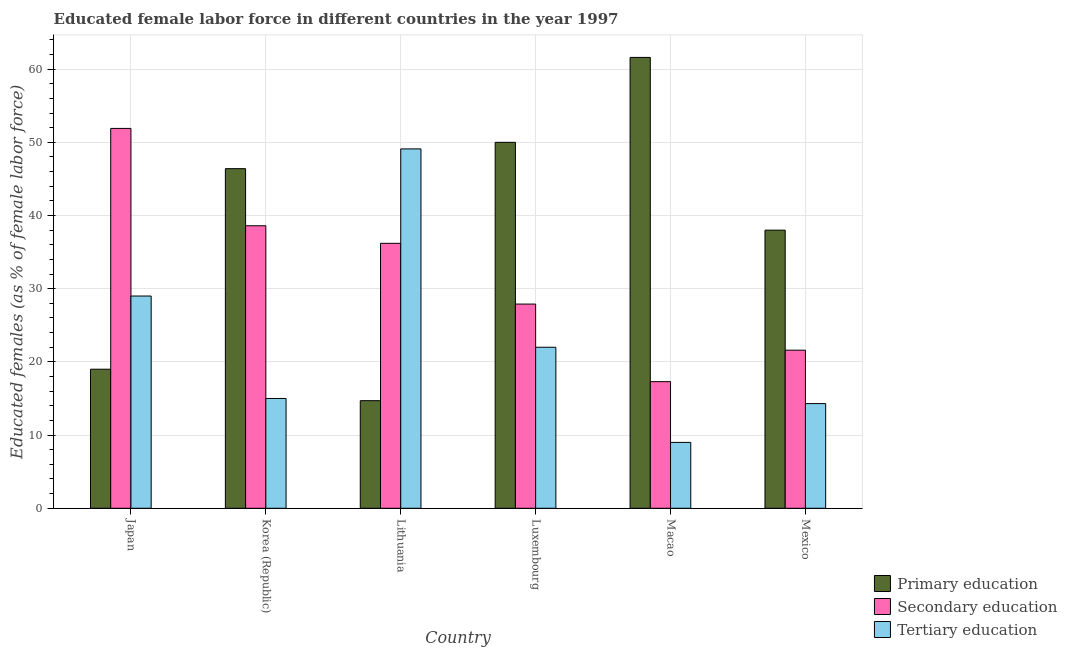How many different coloured bars are there?
Your response must be concise. 3. Are the number of bars per tick equal to the number of legend labels?
Your answer should be very brief. Yes. How many bars are there on the 3rd tick from the right?
Your answer should be compact. 3. What is the label of the 3rd group of bars from the left?
Offer a terse response. Lithuania. What is the percentage of female labor force who received secondary education in Mexico?
Your response must be concise. 21.6. Across all countries, what is the maximum percentage of female labor force who received secondary education?
Your response must be concise. 51.9. Across all countries, what is the minimum percentage of female labor force who received secondary education?
Your answer should be compact. 17.3. In which country was the percentage of female labor force who received tertiary education maximum?
Your answer should be very brief. Lithuania. In which country was the percentage of female labor force who received secondary education minimum?
Your response must be concise. Macao. What is the total percentage of female labor force who received primary education in the graph?
Provide a succinct answer. 229.7. What is the difference between the percentage of female labor force who received primary education in Korea (Republic) and that in Mexico?
Ensure brevity in your answer.  8.4. What is the difference between the percentage of female labor force who received tertiary education in Luxembourg and the percentage of female labor force who received secondary education in Lithuania?
Provide a short and direct response. -14.2. What is the average percentage of female labor force who received secondary education per country?
Offer a very short reply. 32.25. What is the difference between the percentage of female labor force who received secondary education and percentage of female labor force who received tertiary education in Macao?
Your answer should be very brief. 8.3. What is the ratio of the percentage of female labor force who received primary education in Luxembourg to that in Mexico?
Give a very brief answer. 1.32. Is the percentage of female labor force who received tertiary education in Korea (Republic) less than that in Luxembourg?
Your answer should be compact. Yes. What is the difference between the highest and the second highest percentage of female labor force who received tertiary education?
Make the answer very short. 20.1. What is the difference between the highest and the lowest percentage of female labor force who received tertiary education?
Keep it short and to the point. 40.1. In how many countries, is the percentage of female labor force who received secondary education greater than the average percentage of female labor force who received secondary education taken over all countries?
Offer a very short reply. 3. Is the sum of the percentage of female labor force who received tertiary education in Lithuania and Macao greater than the maximum percentage of female labor force who received secondary education across all countries?
Give a very brief answer. Yes. What does the 3rd bar from the left in Lithuania represents?
Offer a very short reply. Tertiary education. What does the 3rd bar from the right in Korea (Republic) represents?
Make the answer very short. Primary education. Is it the case that in every country, the sum of the percentage of female labor force who received primary education and percentage of female labor force who received secondary education is greater than the percentage of female labor force who received tertiary education?
Keep it short and to the point. Yes. How many bars are there?
Offer a terse response. 18. Are all the bars in the graph horizontal?
Your answer should be compact. No. What is the difference between two consecutive major ticks on the Y-axis?
Offer a terse response. 10. Are the values on the major ticks of Y-axis written in scientific E-notation?
Offer a terse response. No. Does the graph contain any zero values?
Offer a terse response. No. What is the title of the graph?
Provide a succinct answer. Educated female labor force in different countries in the year 1997. What is the label or title of the X-axis?
Offer a very short reply. Country. What is the label or title of the Y-axis?
Give a very brief answer. Educated females (as % of female labor force). What is the Educated females (as % of female labor force) in Primary education in Japan?
Provide a short and direct response. 19. What is the Educated females (as % of female labor force) in Secondary education in Japan?
Offer a terse response. 51.9. What is the Educated females (as % of female labor force) of Tertiary education in Japan?
Keep it short and to the point. 29. What is the Educated females (as % of female labor force) of Primary education in Korea (Republic)?
Make the answer very short. 46.4. What is the Educated females (as % of female labor force) of Secondary education in Korea (Republic)?
Your response must be concise. 38.6. What is the Educated females (as % of female labor force) in Tertiary education in Korea (Republic)?
Provide a short and direct response. 15. What is the Educated females (as % of female labor force) in Primary education in Lithuania?
Your answer should be compact. 14.7. What is the Educated females (as % of female labor force) of Secondary education in Lithuania?
Offer a terse response. 36.2. What is the Educated females (as % of female labor force) in Tertiary education in Lithuania?
Offer a terse response. 49.1. What is the Educated females (as % of female labor force) of Secondary education in Luxembourg?
Offer a terse response. 27.9. What is the Educated females (as % of female labor force) in Primary education in Macao?
Your answer should be very brief. 61.6. What is the Educated females (as % of female labor force) of Secondary education in Macao?
Offer a terse response. 17.3. What is the Educated females (as % of female labor force) in Primary education in Mexico?
Give a very brief answer. 38. What is the Educated females (as % of female labor force) of Secondary education in Mexico?
Keep it short and to the point. 21.6. What is the Educated females (as % of female labor force) in Tertiary education in Mexico?
Offer a terse response. 14.3. Across all countries, what is the maximum Educated females (as % of female labor force) of Primary education?
Keep it short and to the point. 61.6. Across all countries, what is the maximum Educated females (as % of female labor force) of Secondary education?
Your response must be concise. 51.9. Across all countries, what is the maximum Educated females (as % of female labor force) in Tertiary education?
Provide a short and direct response. 49.1. Across all countries, what is the minimum Educated females (as % of female labor force) in Primary education?
Your answer should be compact. 14.7. Across all countries, what is the minimum Educated females (as % of female labor force) of Secondary education?
Provide a short and direct response. 17.3. Across all countries, what is the minimum Educated females (as % of female labor force) in Tertiary education?
Make the answer very short. 9. What is the total Educated females (as % of female labor force) of Primary education in the graph?
Your answer should be compact. 229.7. What is the total Educated females (as % of female labor force) of Secondary education in the graph?
Provide a succinct answer. 193.5. What is the total Educated females (as % of female labor force) in Tertiary education in the graph?
Give a very brief answer. 138.4. What is the difference between the Educated females (as % of female labor force) in Primary education in Japan and that in Korea (Republic)?
Provide a short and direct response. -27.4. What is the difference between the Educated females (as % of female labor force) of Tertiary education in Japan and that in Korea (Republic)?
Your response must be concise. 14. What is the difference between the Educated females (as % of female labor force) of Primary education in Japan and that in Lithuania?
Make the answer very short. 4.3. What is the difference between the Educated females (as % of female labor force) in Secondary education in Japan and that in Lithuania?
Offer a terse response. 15.7. What is the difference between the Educated females (as % of female labor force) of Tertiary education in Japan and that in Lithuania?
Your response must be concise. -20.1. What is the difference between the Educated females (as % of female labor force) in Primary education in Japan and that in Luxembourg?
Your answer should be very brief. -31. What is the difference between the Educated females (as % of female labor force) in Secondary education in Japan and that in Luxembourg?
Provide a succinct answer. 24. What is the difference between the Educated females (as % of female labor force) in Primary education in Japan and that in Macao?
Give a very brief answer. -42.6. What is the difference between the Educated females (as % of female labor force) in Secondary education in Japan and that in Macao?
Offer a terse response. 34.6. What is the difference between the Educated females (as % of female labor force) in Secondary education in Japan and that in Mexico?
Provide a short and direct response. 30.3. What is the difference between the Educated females (as % of female labor force) of Primary education in Korea (Republic) and that in Lithuania?
Give a very brief answer. 31.7. What is the difference between the Educated females (as % of female labor force) of Secondary education in Korea (Republic) and that in Lithuania?
Offer a very short reply. 2.4. What is the difference between the Educated females (as % of female labor force) of Tertiary education in Korea (Republic) and that in Lithuania?
Your answer should be very brief. -34.1. What is the difference between the Educated females (as % of female labor force) of Primary education in Korea (Republic) and that in Luxembourg?
Offer a very short reply. -3.6. What is the difference between the Educated females (as % of female labor force) of Secondary education in Korea (Republic) and that in Luxembourg?
Provide a succinct answer. 10.7. What is the difference between the Educated females (as % of female labor force) in Primary education in Korea (Republic) and that in Macao?
Offer a terse response. -15.2. What is the difference between the Educated females (as % of female labor force) in Secondary education in Korea (Republic) and that in Macao?
Give a very brief answer. 21.3. What is the difference between the Educated females (as % of female labor force) of Tertiary education in Korea (Republic) and that in Macao?
Your answer should be compact. 6. What is the difference between the Educated females (as % of female labor force) in Tertiary education in Korea (Republic) and that in Mexico?
Make the answer very short. 0.7. What is the difference between the Educated females (as % of female labor force) in Primary education in Lithuania and that in Luxembourg?
Offer a very short reply. -35.3. What is the difference between the Educated females (as % of female labor force) of Secondary education in Lithuania and that in Luxembourg?
Ensure brevity in your answer.  8.3. What is the difference between the Educated females (as % of female labor force) of Tertiary education in Lithuania and that in Luxembourg?
Offer a very short reply. 27.1. What is the difference between the Educated females (as % of female labor force) of Primary education in Lithuania and that in Macao?
Your answer should be very brief. -46.9. What is the difference between the Educated females (as % of female labor force) in Secondary education in Lithuania and that in Macao?
Make the answer very short. 18.9. What is the difference between the Educated females (as % of female labor force) in Tertiary education in Lithuania and that in Macao?
Provide a succinct answer. 40.1. What is the difference between the Educated females (as % of female labor force) in Primary education in Lithuania and that in Mexico?
Your answer should be compact. -23.3. What is the difference between the Educated females (as % of female labor force) in Tertiary education in Lithuania and that in Mexico?
Give a very brief answer. 34.8. What is the difference between the Educated females (as % of female labor force) of Tertiary education in Luxembourg and that in Macao?
Keep it short and to the point. 13. What is the difference between the Educated females (as % of female labor force) in Secondary education in Luxembourg and that in Mexico?
Give a very brief answer. 6.3. What is the difference between the Educated females (as % of female labor force) in Primary education in Macao and that in Mexico?
Provide a short and direct response. 23.6. What is the difference between the Educated females (as % of female labor force) of Tertiary education in Macao and that in Mexico?
Offer a terse response. -5.3. What is the difference between the Educated females (as % of female labor force) in Primary education in Japan and the Educated females (as % of female labor force) in Secondary education in Korea (Republic)?
Provide a short and direct response. -19.6. What is the difference between the Educated females (as % of female labor force) in Primary education in Japan and the Educated females (as % of female labor force) in Tertiary education in Korea (Republic)?
Your answer should be very brief. 4. What is the difference between the Educated females (as % of female labor force) in Secondary education in Japan and the Educated females (as % of female labor force) in Tertiary education in Korea (Republic)?
Your response must be concise. 36.9. What is the difference between the Educated females (as % of female labor force) in Primary education in Japan and the Educated females (as % of female labor force) in Secondary education in Lithuania?
Make the answer very short. -17.2. What is the difference between the Educated females (as % of female labor force) of Primary education in Japan and the Educated females (as % of female labor force) of Tertiary education in Lithuania?
Give a very brief answer. -30.1. What is the difference between the Educated females (as % of female labor force) of Primary education in Japan and the Educated females (as % of female labor force) of Secondary education in Luxembourg?
Give a very brief answer. -8.9. What is the difference between the Educated females (as % of female labor force) of Primary education in Japan and the Educated females (as % of female labor force) of Tertiary education in Luxembourg?
Provide a succinct answer. -3. What is the difference between the Educated females (as % of female labor force) in Secondary education in Japan and the Educated females (as % of female labor force) in Tertiary education in Luxembourg?
Provide a short and direct response. 29.9. What is the difference between the Educated females (as % of female labor force) of Primary education in Japan and the Educated females (as % of female labor force) of Tertiary education in Macao?
Your answer should be very brief. 10. What is the difference between the Educated females (as % of female labor force) of Secondary education in Japan and the Educated females (as % of female labor force) of Tertiary education in Macao?
Keep it short and to the point. 42.9. What is the difference between the Educated females (as % of female labor force) of Primary education in Japan and the Educated females (as % of female labor force) of Secondary education in Mexico?
Your response must be concise. -2.6. What is the difference between the Educated females (as % of female labor force) of Secondary education in Japan and the Educated females (as % of female labor force) of Tertiary education in Mexico?
Your answer should be compact. 37.6. What is the difference between the Educated females (as % of female labor force) in Primary education in Korea (Republic) and the Educated females (as % of female labor force) in Secondary education in Lithuania?
Make the answer very short. 10.2. What is the difference between the Educated females (as % of female labor force) in Primary education in Korea (Republic) and the Educated females (as % of female labor force) in Tertiary education in Lithuania?
Your answer should be compact. -2.7. What is the difference between the Educated females (as % of female labor force) of Secondary education in Korea (Republic) and the Educated females (as % of female labor force) of Tertiary education in Lithuania?
Provide a succinct answer. -10.5. What is the difference between the Educated females (as % of female labor force) of Primary education in Korea (Republic) and the Educated females (as % of female labor force) of Secondary education in Luxembourg?
Keep it short and to the point. 18.5. What is the difference between the Educated females (as % of female labor force) in Primary education in Korea (Republic) and the Educated females (as % of female labor force) in Tertiary education in Luxembourg?
Provide a short and direct response. 24.4. What is the difference between the Educated females (as % of female labor force) of Primary education in Korea (Republic) and the Educated females (as % of female labor force) of Secondary education in Macao?
Give a very brief answer. 29.1. What is the difference between the Educated females (as % of female labor force) in Primary education in Korea (Republic) and the Educated females (as % of female labor force) in Tertiary education in Macao?
Provide a short and direct response. 37.4. What is the difference between the Educated females (as % of female labor force) of Secondary education in Korea (Republic) and the Educated females (as % of female labor force) of Tertiary education in Macao?
Your answer should be compact. 29.6. What is the difference between the Educated females (as % of female labor force) in Primary education in Korea (Republic) and the Educated females (as % of female labor force) in Secondary education in Mexico?
Your answer should be very brief. 24.8. What is the difference between the Educated females (as % of female labor force) of Primary education in Korea (Republic) and the Educated females (as % of female labor force) of Tertiary education in Mexico?
Keep it short and to the point. 32.1. What is the difference between the Educated females (as % of female labor force) of Secondary education in Korea (Republic) and the Educated females (as % of female labor force) of Tertiary education in Mexico?
Offer a terse response. 24.3. What is the difference between the Educated females (as % of female labor force) of Primary education in Lithuania and the Educated females (as % of female labor force) of Secondary education in Luxembourg?
Keep it short and to the point. -13.2. What is the difference between the Educated females (as % of female labor force) of Secondary education in Lithuania and the Educated females (as % of female labor force) of Tertiary education in Luxembourg?
Ensure brevity in your answer.  14.2. What is the difference between the Educated females (as % of female labor force) of Secondary education in Lithuania and the Educated females (as % of female labor force) of Tertiary education in Macao?
Provide a succinct answer. 27.2. What is the difference between the Educated females (as % of female labor force) in Secondary education in Lithuania and the Educated females (as % of female labor force) in Tertiary education in Mexico?
Make the answer very short. 21.9. What is the difference between the Educated females (as % of female labor force) in Primary education in Luxembourg and the Educated females (as % of female labor force) in Secondary education in Macao?
Ensure brevity in your answer.  32.7. What is the difference between the Educated females (as % of female labor force) in Primary education in Luxembourg and the Educated females (as % of female labor force) in Tertiary education in Macao?
Your answer should be very brief. 41. What is the difference between the Educated females (as % of female labor force) in Primary education in Luxembourg and the Educated females (as % of female labor force) in Secondary education in Mexico?
Ensure brevity in your answer.  28.4. What is the difference between the Educated females (as % of female labor force) in Primary education in Luxembourg and the Educated females (as % of female labor force) in Tertiary education in Mexico?
Give a very brief answer. 35.7. What is the difference between the Educated females (as % of female labor force) in Primary education in Macao and the Educated females (as % of female labor force) in Tertiary education in Mexico?
Your answer should be very brief. 47.3. What is the average Educated females (as % of female labor force) of Primary education per country?
Keep it short and to the point. 38.28. What is the average Educated females (as % of female labor force) of Secondary education per country?
Your response must be concise. 32.25. What is the average Educated females (as % of female labor force) of Tertiary education per country?
Give a very brief answer. 23.07. What is the difference between the Educated females (as % of female labor force) in Primary education and Educated females (as % of female labor force) in Secondary education in Japan?
Give a very brief answer. -32.9. What is the difference between the Educated females (as % of female labor force) in Primary education and Educated females (as % of female labor force) in Tertiary education in Japan?
Offer a terse response. -10. What is the difference between the Educated females (as % of female labor force) of Secondary education and Educated females (as % of female labor force) of Tertiary education in Japan?
Make the answer very short. 22.9. What is the difference between the Educated females (as % of female labor force) in Primary education and Educated females (as % of female labor force) in Secondary education in Korea (Republic)?
Provide a succinct answer. 7.8. What is the difference between the Educated females (as % of female labor force) of Primary education and Educated females (as % of female labor force) of Tertiary education in Korea (Republic)?
Offer a terse response. 31.4. What is the difference between the Educated females (as % of female labor force) in Secondary education and Educated females (as % of female labor force) in Tertiary education in Korea (Republic)?
Offer a very short reply. 23.6. What is the difference between the Educated females (as % of female labor force) of Primary education and Educated females (as % of female labor force) of Secondary education in Lithuania?
Keep it short and to the point. -21.5. What is the difference between the Educated females (as % of female labor force) in Primary education and Educated females (as % of female labor force) in Tertiary education in Lithuania?
Your response must be concise. -34.4. What is the difference between the Educated females (as % of female labor force) in Secondary education and Educated females (as % of female labor force) in Tertiary education in Lithuania?
Ensure brevity in your answer.  -12.9. What is the difference between the Educated females (as % of female labor force) in Primary education and Educated females (as % of female labor force) in Secondary education in Luxembourg?
Give a very brief answer. 22.1. What is the difference between the Educated females (as % of female labor force) in Primary education and Educated females (as % of female labor force) in Tertiary education in Luxembourg?
Provide a succinct answer. 28. What is the difference between the Educated females (as % of female labor force) in Secondary education and Educated females (as % of female labor force) in Tertiary education in Luxembourg?
Offer a very short reply. 5.9. What is the difference between the Educated females (as % of female labor force) in Primary education and Educated females (as % of female labor force) in Secondary education in Macao?
Ensure brevity in your answer.  44.3. What is the difference between the Educated females (as % of female labor force) of Primary education and Educated females (as % of female labor force) of Tertiary education in Macao?
Keep it short and to the point. 52.6. What is the difference between the Educated females (as % of female labor force) of Secondary education and Educated females (as % of female labor force) of Tertiary education in Macao?
Offer a terse response. 8.3. What is the difference between the Educated females (as % of female labor force) of Primary education and Educated females (as % of female labor force) of Secondary education in Mexico?
Your answer should be very brief. 16.4. What is the difference between the Educated females (as % of female labor force) in Primary education and Educated females (as % of female labor force) in Tertiary education in Mexico?
Provide a short and direct response. 23.7. What is the ratio of the Educated females (as % of female labor force) of Primary education in Japan to that in Korea (Republic)?
Make the answer very short. 0.41. What is the ratio of the Educated females (as % of female labor force) in Secondary education in Japan to that in Korea (Republic)?
Provide a short and direct response. 1.34. What is the ratio of the Educated females (as % of female labor force) of Tertiary education in Japan to that in Korea (Republic)?
Your answer should be very brief. 1.93. What is the ratio of the Educated females (as % of female labor force) in Primary education in Japan to that in Lithuania?
Your answer should be very brief. 1.29. What is the ratio of the Educated females (as % of female labor force) of Secondary education in Japan to that in Lithuania?
Your response must be concise. 1.43. What is the ratio of the Educated females (as % of female labor force) of Tertiary education in Japan to that in Lithuania?
Provide a short and direct response. 0.59. What is the ratio of the Educated females (as % of female labor force) in Primary education in Japan to that in Luxembourg?
Give a very brief answer. 0.38. What is the ratio of the Educated females (as % of female labor force) of Secondary education in Japan to that in Luxembourg?
Give a very brief answer. 1.86. What is the ratio of the Educated females (as % of female labor force) in Tertiary education in Japan to that in Luxembourg?
Provide a succinct answer. 1.32. What is the ratio of the Educated females (as % of female labor force) of Primary education in Japan to that in Macao?
Give a very brief answer. 0.31. What is the ratio of the Educated females (as % of female labor force) in Tertiary education in Japan to that in Macao?
Offer a very short reply. 3.22. What is the ratio of the Educated females (as % of female labor force) in Secondary education in Japan to that in Mexico?
Offer a terse response. 2.4. What is the ratio of the Educated females (as % of female labor force) of Tertiary education in Japan to that in Mexico?
Ensure brevity in your answer.  2.03. What is the ratio of the Educated females (as % of female labor force) of Primary education in Korea (Republic) to that in Lithuania?
Your answer should be very brief. 3.16. What is the ratio of the Educated females (as % of female labor force) in Secondary education in Korea (Republic) to that in Lithuania?
Ensure brevity in your answer.  1.07. What is the ratio of the Educated females (as % of female labor force) in Tertiary education in Korea (Republic) to that in Lithuania?
Give a very brief answer. 0.31. What is the ratio of the Educated females (as % of female labor force) of Primary education in Korea (Republic) to that in Luxembourg?
Make the answer very short. 0.93. What is the ratio of the Educated females (as % of female labor force) in Secondary education in Korea (Republic) to that in Luxembourg?
Keep it short and to the point. 1.38. What is the ratio of the Educated females (as % of female labor force) of Tertiary education in Korea (Republic) to that in Luxembourg?
Provide a succinct answer. 0.68. What is the ratio of the Educated females (as % of female labor force) in Primary education in Korea (Republic) to that in Macao?
Provide a succinct answer. 0.75. What is the ratio of the Educated females (as % of female labor force) of Secondary education in Korea (Republic) to that in Macao?
Your answer should be compact. 2.23. What is the ratio of the Educated females (as % of female labor force) of Tertiary education in Korea (Republic) to that in Macao?
Your response must be concise. 1.67. What is the ratio of the Educated females (as % of female labor force) in Primary education in Korea (Republic) to that in Mexico?
Give a very brief answer. 1.22. What is the ratio of the Educated females (as % of female labor force) in Secondary education in Korea (Republic) to that in Mexico?
Keep it short and to the point. 1.79. What is the ratio of the Educated females (as % of female labor force) in Tertiary education in Korea (Republic) to that in Mexico?
Provide a succinct answer. 1.05. What is the ratio of the Educated females (as % of female labor force) of Primary education in Lithuania to that in Luxembourg?
Your answer should be compact. 0.29. What is the ratio of the Educated females (as % of female labor force) in Secondary education in Lithuania to that in Luxembourg?
Make the answer very short. 1.3. What is the ratio of the Educated females (as % of female labor force) in Tertiary education in Lithuania to that in Luxembourg?
Ensure brevity in your answer.  2.23. What is the ratio of the Educated females (as % of female labor force) of Primary education in Lithuania to that in Macao?
Give a very brief answer. 0.24. What is the ratio of the Educated females (as % of female labor force) in Secondary education in Lithuania to that in Macao?
Give a very brief answer. 2.09. What is the ratio of the Educated females (as % of female labor force) of Tertiary education in Lithuania to that in Macao?
Offer a terse response. 5.46. What is the ratio of the Educated females (as % of female labor force) in Primary education in Lithuania to that in Mexico?
Your answer should be compact. 0.39. What is the ratio of the Educated females (as % of female labor force) in Secondary education in Lithuania to that in Mexico?
Offer a very short reply. 1.68. What is the ratio of the Educated females (as % of female labor force) of Tertiary education in Lithuania to that in Mexico?
Keep it short and to the point. 3.43. What is the ratio of the Educated females (as % of female labor force) of Primary education in Luxembourg to that in Macao?
Give a very brief answer. 0.81. What is the ratio of the Educated females (as % of female labor force) of Secondary education in Luxembourg to that in Macao?
Ensure brevity in your answer.  1.61. What is the ratio of the Educated females (as % of female labor force) in Tertiary education in Luxembourg to that in Macao?
Keep it short and to the point. 2.44. What is the ratio of the Educated females (as % of female labor force) in Primary education in Luxembourg to that in Mexico?
Your answer should be very brief. 1.32. What is the ratio of the Educated females (as % of female labor force) of Secondary education in Luxembourg to that in Mexico?
Provide a short and direct response. 1.29. What is the ratio of the Educated females (as % of female labor force) in Tertiary education in Luxembourg to that in Mexico?
Ensure brevity in your answer.  1.54. What is the ratio of the Educated females (as % of female labor force) of Primary education in Macao to that in Mexico?
Ensure brevity in your answer.  1.62. What is the ratio of the Educated females (as % of female labor force) in Secondary education in Macao to that in Mexico?
Ensure brevity in your answer.  0.8. What is the ratio of the Educated females (as % of female labor force) in Tertiary education in Macao to that in Mexico?
Ensure brevity in your answer.  0.63. What is the difference between the highest and the second highest Educated females (as % of female labor force) of Primary education?
Keep it short and to the point. 11.6. What is the difference between the highest and the second highest Educated females (as % of female labor force) of Tertiary education?
Your response must be concise. 20.1. What is the difference between the highest and the lowest Educated females (as % of female labor force) in Primary education?
Provide a short and direct response. 46.9. What is the difference between the highest and the lowest Educated females (as % of female labor force) in Secondary education?
Offer a terse response. 34.6. What is the difference between the highest and the lowest Educated females (as % of female labor force) of Tertiary education?
Your response must be concise. 40.1. 